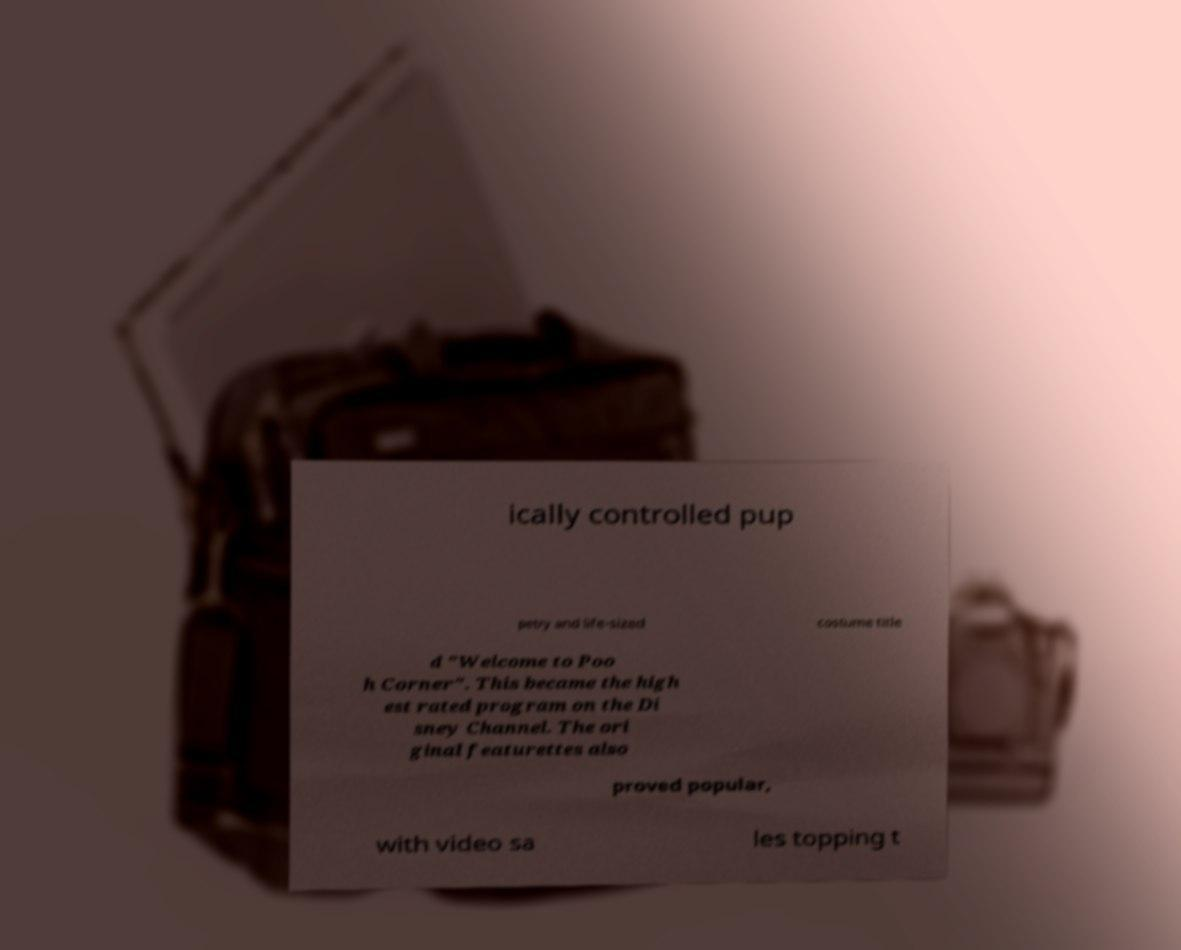Could you assist in decoding the text presented in this image and type it out clearly? ically controlled pup petry and life-sized costume title d "Welcome to Poo h Corner". This became the high est rated program on the Di sney Channel. The ori ginal featurettes also proved popular, with video sa les topping t 